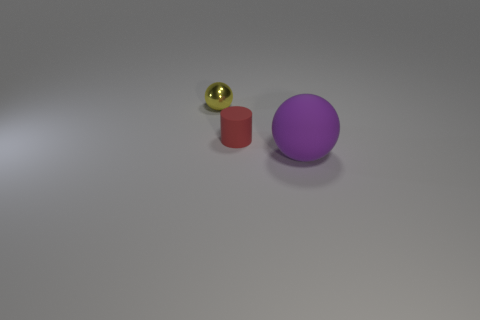Add 2 cylinders. How many objects exist? 5 Subtract all spheres. How many objects are left? 1 Add 1 tiny yellow metal spheres. How many tiny yellow metal spheres exist? 2 Subtract 1 red cylinders. How many objects are left? 2 Subtract all green rubber things. Subtract all small objects. How many objects are left? 1 Add 3 big rubber spheres. How many big rubber spheres are left? 4 